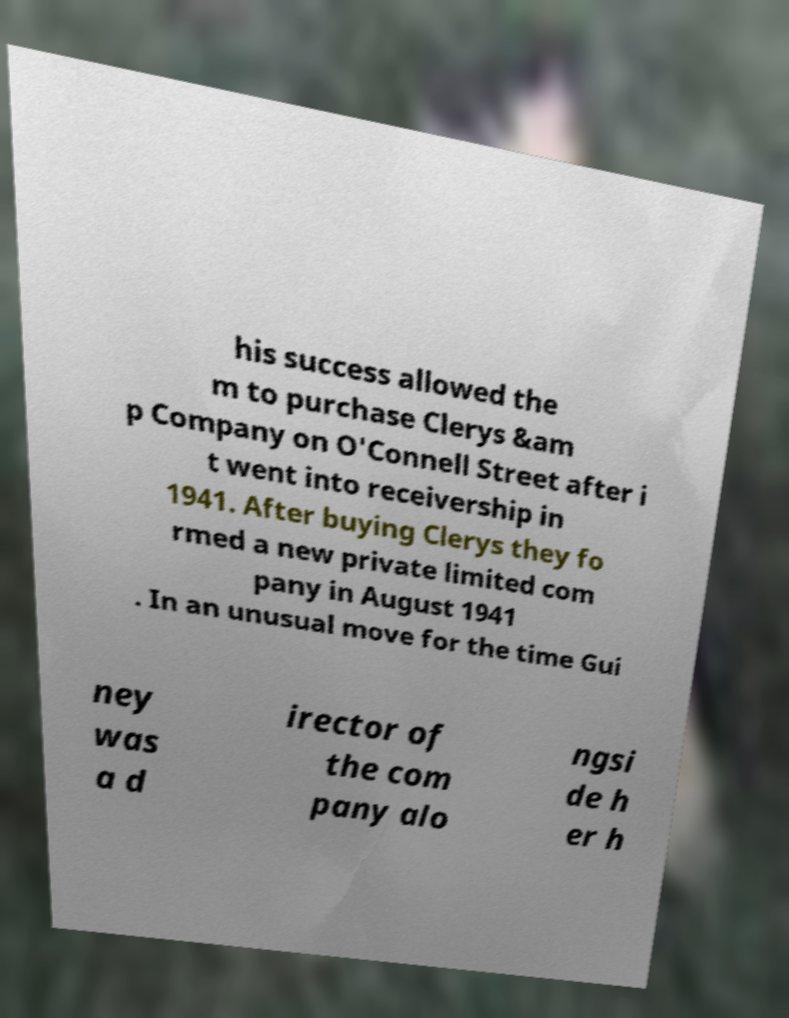I need the written content from this picture converted into text. Can you do that? his success allowed the m to purchase Clerys &am p Company on O'Connell Street after i t went into receivership in 1941. After buying Clerys they fo rmed a new private limited com pany in August 1941 . In an unusual move for the time Gui ney was a d irector of the com pany alo ngsi de h er h 